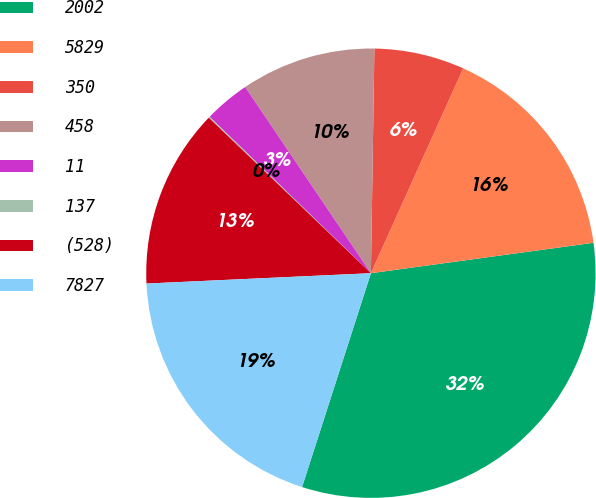<chart> <loc_0><loc_0><loc_500><loc_500><pie_chart><fcel>2002<fcel>5829<fcel>350<fcel>458<fcel>11<fcel>137<fcel>(528)<fcel>7827<nl><fcel>32.12%<fcel>16.1%<fcel>6.49%<fcel>9.7%<fcel>3.29%<fcel>0.09%<fcel>12.9%<fcel>19.31%<nl></chart> 